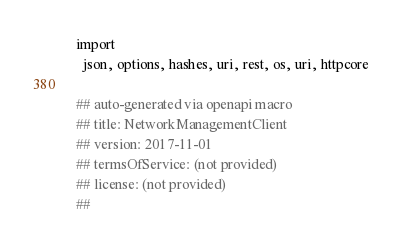<code> <loc_0><loc_0><loc_500><loc_500><_Nim_>
import
  json, options, hashes, uri, rest, os, uri, httpcore

## auto-generated via openapi macro
## title: NetworkManagementClient
## version: 2017-11-01
## termsOfService: (not provided)
## license: (not provided)
## </code> 